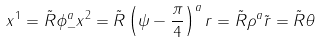<formula> <loc_0><loc_0><loc_500><loc_500>x ^ { 1 } = \tilde { R } \phi _ { - } ^ { a } x ^ { 2 } = \tilde { R } \left ( \psi - \frac { \pi } { 4 } \right ) ^ { a } r = \tilde { R } \rho ^ { a } \tilde { r } = \tilde { R } \theta</formula> 